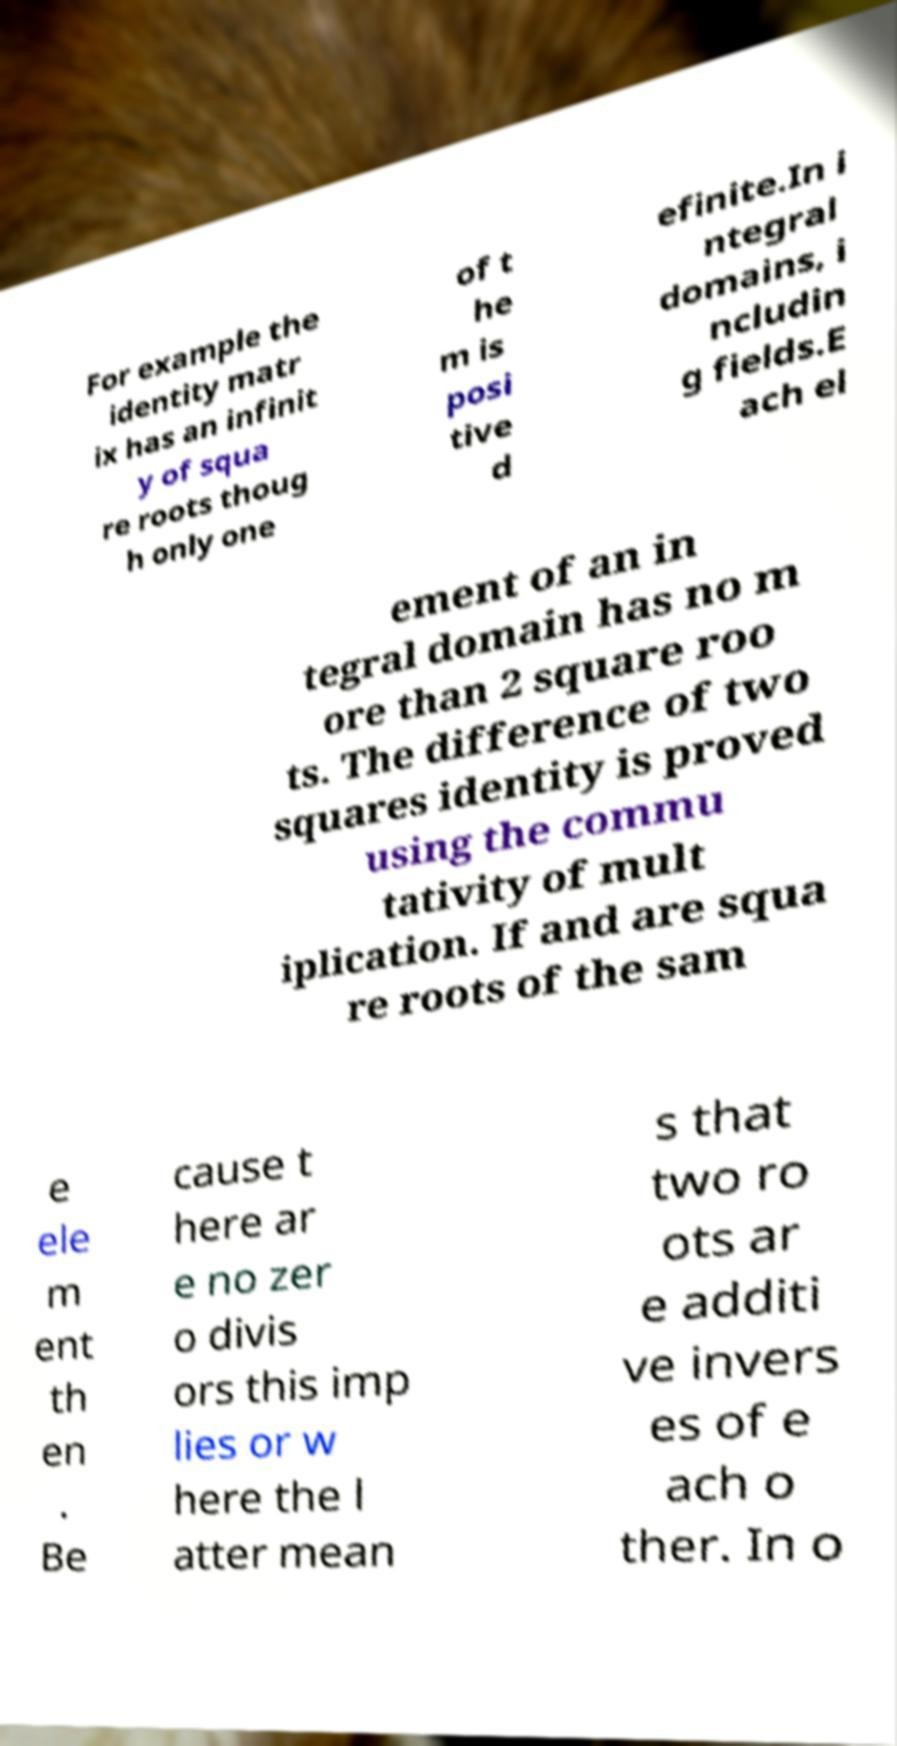For documentation purposes, I need the text within this image transcribed. Could you provide that? For example the identity matr ix has an infinit y of squa re roots thoug h only one of t he m is posi tive d efinite.In i ntegral domains, i ncludin g fields.E ach el ement of an in tegral domain has no m ore than 2 square roo ts. The difference of two squares identity is proved using the commu tativity of mult iplication. If and are squa re roots of the sam e ele m ent th en . Be cause t here ar e no zer o divis ors this imp lies or w here the l atter mean s that two ro ots ar e additi ve invers es of e ach o ther. In o 